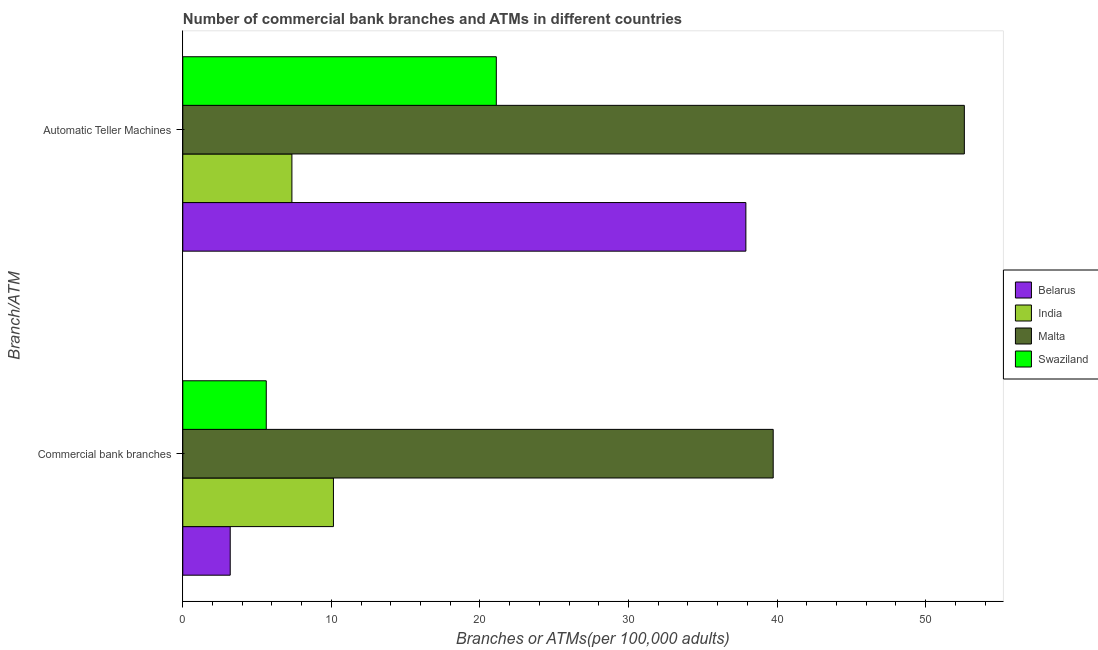Are the number of bars per tick equal to the number of legend labels?
Provide a short and direct response. Yes. How many bars are there on the 2nd tick from the top?
Ensure brevity in your answer.  4. How many bars are there on the 2nd tick from the bottom?
Your response must be concise. 4. What is the label of the 2nd group of bars from the top?
Make the answer very short. Commercial bank branches. What is the number of atms in Malta?
Your answer should be compact. 52.61. Across all countries, what is the maximum number of commercal bank branches?
Give a very brief answer. 39.74. Across all countries, what is the minimum number of commercal bank branches?
Offer a very short reply. 3.19. In which country was the number of commercal bank branches maximum?
Give a very brief answer. Malta. In which country was the number of commercal bank branches minimum?
Make the answer very short. Belarus. What is the total number of atms in the graph?
Give a very brief answer. 118.96. What is the difference between the number of atms in India and that in Swaziland?
Ensure brevity in your answer.  -13.76. What is the difference between the number of atms in India and the number of commercal bank branches in Swaziland?
Make the answer very short. 1.73. What is the average number of commercal bank branches per country?
Offer a terse response. 14.67. What is the difference between the number of atms and number of commercal bank branches in Belarus?
Ensure brevity in your answer.  34.71. In how many countries, is the number of atms greater than 16 ?
Keep it short and to the point. 3. What is the ratio of the number of commercal bank branches in Belarus to that in India?
Ensure brevity in your answer.  0.31. Is the number of commercal bank branches in Swaziland less than that in India?
Your response must be concise. Yes. In how many countries, is the number of commercal bank branches greater than the average number of commercal bank branches taken over all countries?
Provide a short and direct response. 1. What does the 2nd bar from the top in Automatic Teller Machines represents?
Ensure brevity in your answer.  Malta. What does the 3rd bar from the bottom in Automatic Teller Machines represents?
Make the answer very short. Malta. How many bars are there?
Provide a short and direct response. 8. Are all the bars in the graph horizontal?
Make the answer very short. Yes. What is the difference between two consecutive major ticks on the X-axis?
Provide a succinct answer. 10. Does the graph contain grids?
Ensure brevity in your answer.  No. Where does the legend appear in the graph?
Provide a succinct answer. Center right. What is the title of the graph?
Your answer should be very brief. Number of commercial bank branches and ATMs in different countries. What is the label or title of the X-axis?
Provide a succinct answer. Branches or ATMs(per 100,0 adults). What is the label or title of the Y-axis?
Offer a terse response. Branch/ATM. What is the Branches or ATMs(per 100,000 adults) in Belarus in Commercial bank branches?
Provide a short and direct response. 3.19. What is the Branches or ATMs(per 100,000 adults) of India in Commercial bank branches?
Provide a short and direct response. 10.14. What is the Branches or ATMs(per 100,000 adults) of Malta in Commercial bank branches?
Ensure brevity in your answer.  39.74. What is the Branches or ATMs(per 100,000 adults) of Swaziland in Commercial bank branches?
Your response must be concise. 5.62. What is the Branches or ATMs(per 100,000 adults) of Belarus in Automatic Teller Machines?
Ensure brevity in your answer.  37.9. What is the Branches or ATMs(per 100,000 adults) of India in Automatic Teller Machines?
Provide a short and direct response. 7.34. What is the Branches or ATMs(per 100,000 adults) of Malta in Automatic Teller Machines?
Provide a succinct answer. 52.61. What is the Branches or ATMs(per 100,000 adults) in Swaziland in Automatic Teller Machines?
Your response must be concise. 21.1. Across all Branch/ATM, what is the maximum Branches or ATMs(per 100,000 adults) of Belarus?
Your answer should be compact. 37.9. Across all Branch/ATM, what is the maximum Branches or ATMs(per 100,000 adults) in India?
Your response must be concise. 10.14. Across all Branch/ATM, what is the maximum Branches or ATMs(per 100,000 adults) of Malta?
Provide a succinct answer. 52.61. Across all Branch/ATM, what is the maximum Branches or ATMs(per 100,000 adults) of Swaziland?
Provide a succinct answer. 21.1. Across all Branch/ATM, what is the minimum Branches or ATMs(per 100,000 adults) in Belarus?
Ensure brevity in your answer.  3.19. Across all Branch/ATM, what is the minimum Branches or ATMs(per 100,000 adults) of India?
Make the answer very short. 7.34. Across all Branch/ATM, what is the minimum Branches or ATMs(per 100,000 adults) in Malta?
Provide a short and direct response. 39.74. Across all Branch/ATM, what is the minimum Branches or ATMs(per 100,000 adults) of Swaziland?
Give a very brief answer. 5.62. What is the total Branches or ATMs(per 100,000 adults) in Belarus in the graph?
Provide a succinct answer. 41.1. What is the total Branches or ATMs(per 100,000 adults) of India in the graph?
Your answer should be compact. 17.49. What is the total Branches or ATMs(per 100,000 adults) in Malta in the graph?
Provide a short and direct response. 92.35. What is the total Branches or ATMs(per 100,000 adults) of Swaziland in the graph?
Your answer should be compact. 26.72. What is the difference between the Branches or ATMs(per 100,000 adults) in Belarus in Commercial bank branches and that in Automatic Teller Machines?
Provide a short and direct response. -34.71. What is the difference between the Branches or ATMs(per 100,000 adults) of India in Commercial bank branches and that in Automatic Teller Machines?
Your answer should be compact. 2.8. What is the difference between the Branches or ATMs(per 100,000 adults) in Malta in Commercial bank branches and that in Automatic Teller Machines?
Make the answer very short. -12.87. What is the difference between the Branches or ATMs(per 100,000 adults) of Swaziland in Commercial bank branches and that in Automatic Teller Machines?
Keep it short and to the point. -15.49. What is the difference between the Branches or ATMs(per 100,000 adults) of Belarus in Commercial bank branches and the Branches or ATMs(per 100,000 adults) of India in Automatic Teller Machines?
Provide a succinct answer. -4.15. What is the difference between the Branches or ATMs(per 100,000 adults) in Belarus in Commercial bank branches and the Branches or ATMs(per 100,000 adults) in Malta in Automatic Teller Machines?
Offer a very short reply. -49.42. What is the difference between the Branches or ATMs(per 100,000 adults) of Belarus in Commercial bank branches and the Branches or ATMs(per 100,000 adults) of Swaziland in Automatic Teller Machines?
Your response must be concise. -17.91. What is the difference between the Branches or ATMs(per 100,000 adults) in India in Commercial bank branches and the Branches or ATMs(per 100,000 adults) in Malta in Automatic Teller Machines?
Make the answer very short. -42.47. What is the difference between the Branches or ATMs(per 100,000 adults) of India in Commercial bank branches and the Branches or ATMs(per 100,000 adults) of Swaziland in Automatic Teller Machines?
Give a very brief answer. -10.96. What is the difference between the Branches or ATMs(per 100,000 adults) of Malta in Commercial bank branches and the Branches or ATMs(per 100,000 adults) of Swaziland in Automatic Teller Machines?
Keep it short and to the point. 18.64. What is the average Branches or ATMs(per 100,000 adults) in Belarus per Branch/ATM?
Offer a terse response. 20.55. What is the average Branches or ATMs(per 100,000 adults) of India per Branch/ATM?
Keep it short and to the point. 8.74. What is the average Branches or ATMs(per 100,000 adults) in Malta per Branch/ATM?
Offer a very short reply. 46.18. What is the average Branches or ATMs(per 100,000 adults) in Swaziland per Branch/ATM?
Provide a short and direct response. 13.36. What is the difference between the Branches or ATMs(per 100,000 adults) in Belarus and Branches or ATMs(per 100,000 adults) in India in Commercial bank branches?
Give a very brief answer. -6.95. What is the difference between the Branches or ATMs(per 100,000 adults) in Belarus and Branches or ATMs(per 100,000 adults) in Malta in Commercial bank branches?
Provide a succinct answer. -36.55. What is the difference between the Branches or ATMs(per 100,000 adults) in Belarus and Branches or ATMs(per 100,000 adults) in Swaziland in Commercial bank branches?
Ensure brevity in your answer.  -2.43. What is the difference between the Branches or ATMs(per 100,000 adults) of India and Branches or ATMs(per 100,000 adults) of Malta in Commercial bank branches?
Ensure brevity in your answer.  -29.6. What is the difference between the Branches or ATMs(per 100,000 adults) of India and Branches or ATMs(per 100,000 adults) of Swaziland in Commercial bank branches?
Your response must be concise. 4.52. What is the difference between the Branches or ATMs(per 100,000 adults) of Malta and Branches or ATMs(per 100,000 adults) of Swaziland in Commercial bank branches?
Offer a terse response. 34.12. What is the difference between the Branches or ATMs(per 100,000 adults) in Belarus and Branches or ATMs(per 100,000 adults) in India in Automatic Teller Machines?
Ensure brevity in your answer.  30.56. What is the difference between the Branches or ATMs(per 100,000 adults) of Belarus and Branches or ATMs(per 100,000 adults) of Malta in Automatic Teller Machines?
Give a very brief answer. -14.71. What is the difference between the Branches or ATMs(per 100,000 adults) of Belarus and Branches or ATMs(per 100,000 adults) of Swaziland in Automatic Teller Machines?
Your response must be concise. 16.8. What is the difference between the Branches or ATMs(per 100,000 adults) of India and Branches or ATMs(per 100,000 adults) of Malta in Automatic Teller Machines?
Offer a very short reply. -45.26. What is the difference between the Branches or ATMs(per 100,000 adults) in India and Branches or ATMs(per 100,000 adults) in Swaziland in Automatic Teller Machines?
Offer a very short reply. -13.76. What is the difference between the Branches or ATMs(per 100,000 adults) of Malta and Branches or ATMs(per 100,000 adults) of Swaziland in Automatic Teller Machines?
Provide a short and direct response. 31.51. What is the ratio of the Branches or ATMs(per 100,000 adults) in Belarus in Commercial bank branches to that in Automatic Teller Machines?
Provide a succinct answer. 0.08. What is the ratio of the Branches or ATMs(per 100,000 adults) in India in Commercial bank branches to that in Automatic Teller Machines?
Make the answer very short. 1.38. What is the ratio of the Branches or ATMs(per 100,000 adults) in Malta in Commercial bank branches to that in Automatic Teller Machines?
Your answer should be very brief. 0.76. What is the ratio of the Branches or ATMs(per 100,000 adults) in Swaziland in Commercial bank branches to that in Automatic Teller Machines?
Make the answer very short. 0.27. What is the difference between the highest and the second highest Branches or ATMs(per 100,000 adults) of Belarus?
Give a very brief answer. 34.71. What is the difference between the highest and the second highest Branches or ATMs(per 100,000 adults) of India?
Offer a very short reply. 2.8. What is the difference between the highest and the second highest Branches or ATMs(per 100,000 adults) of Malta?
Provide a succinct answer. 12.87. What is the difference between the highest and the second highest Branches or ATMs(per 100,000 adults) of Swaziland?
Provide a succinct answer. 15.49. What is the difference between the highest and the lowest Branches or ATMs(per 100,000 adults) of Belarus?
Your response must be concise. 34.71. What is the difference between the highest and the lowest Branches or ATMs(per 100,000 adults) of India?
Offer a terse response. 2.8. What is the difference between the highest and the lowest Branches or ATMs(per 100,000 adults) of Malta?
Offer a very short reply. 12.87. What is the difference between the highest and the lowest Branches or ATMs(per 100,000 adults) of Swaziland?
Keep it short and to the point. 15.49. 